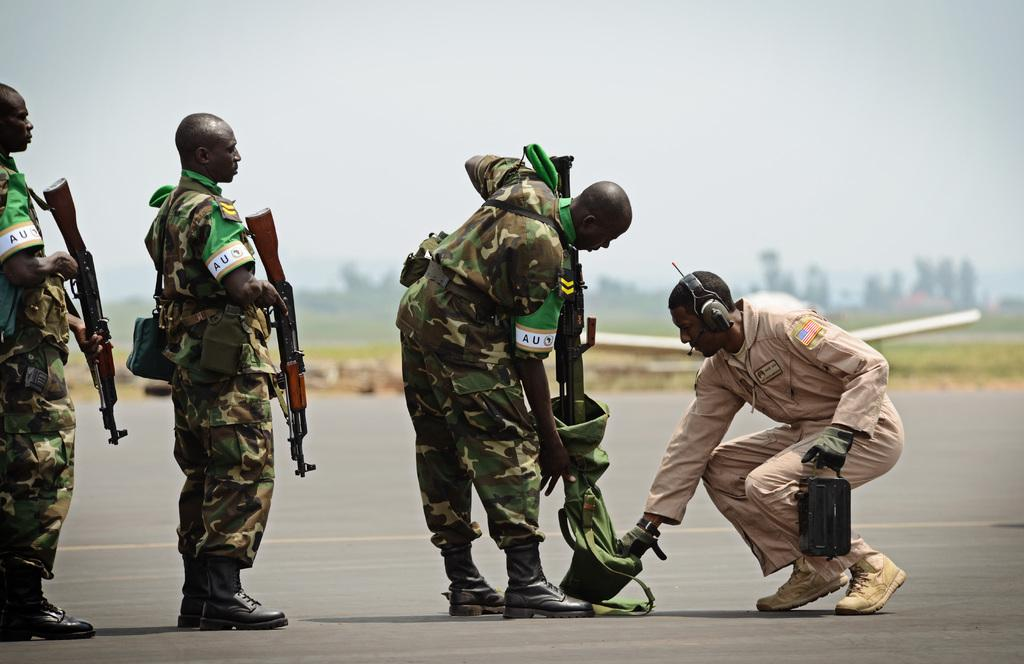What can be seen in the image? There are people standing in the image. What are the people wearing? The people are wearing uniforms. What are the people holding? The people are holding rifles. What is visible in the background of the image? There are trees in the background of the image. What is the condition of the sky in the image? The sky is clear in the image. What type of mouth can be seen on the trees in the image? There are no mouths present on the trees in the image, as trees do not have mouths. 